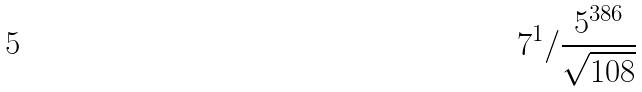<formula> <loc_0><loc_0><loc_500><loc_500>7 ^ { 1 } / \frac { 5 ^ { 3 8 6 } } { \sqrt { 1 0 8 } }</formula> 